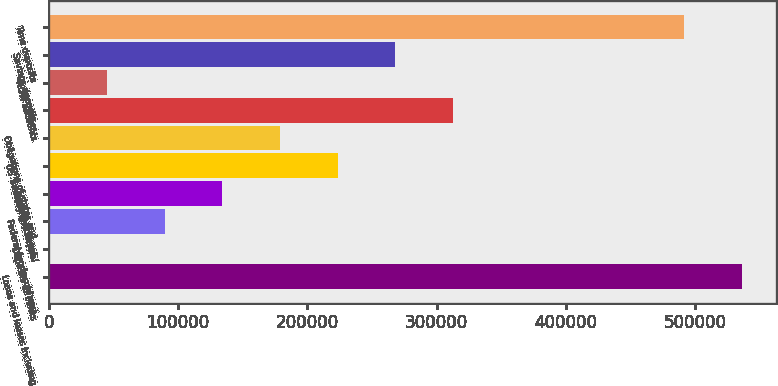Convert chart to OTSL. <chart><loc_0><loc_0><loc_500><loc_500><bar_chart><fcel>Loans and leases including<fcel>Deposits at banks<fcel>Federal funds sold and<fcel>Trading account<fcel>US Treasury and federal<fcel>Obligations of states and<fcel>Other<fcel>NOW accounts<fcel>Savings deposits<fcel>Time deposits<nl><fcel>536094<fcel>104<fcel>89435.6<fcel>134101<fcel>223433<fcel>178767<fcel>312765<fcel>44769.8<fcel>268099<fcel>491428<nl></chart> 